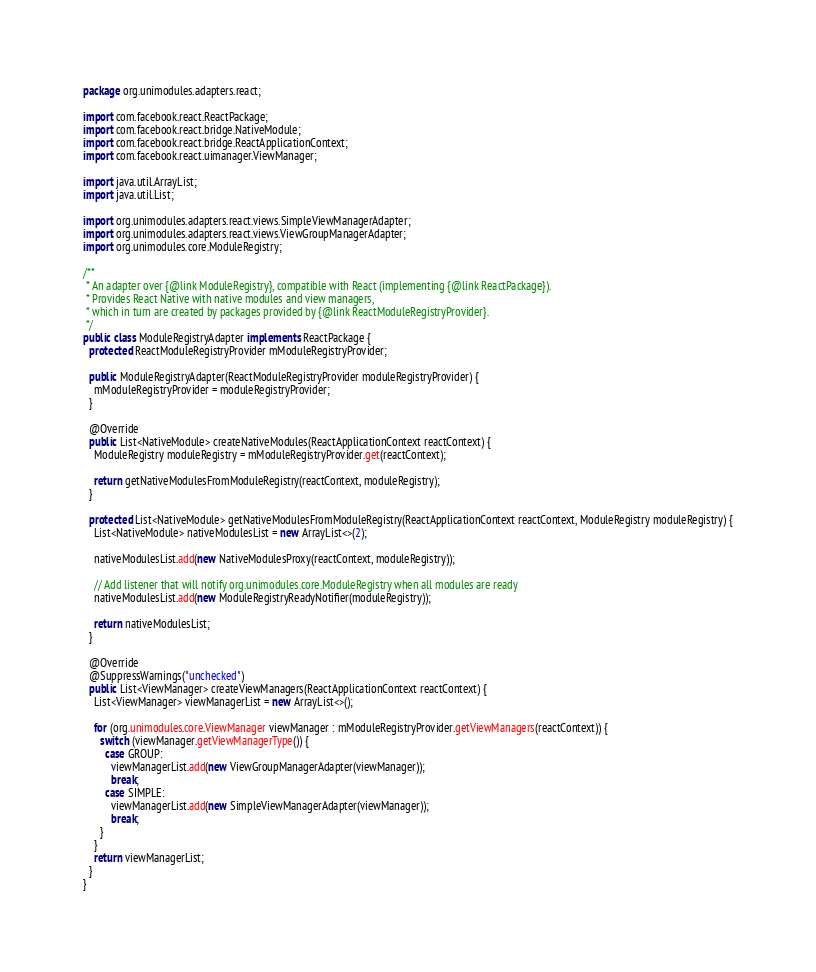Convert code to text. <code><loc_0><loc_0><loc_500><loc_500><_Java_>package org.unimodules.adapters.react;

import com.facebook.react.ReactPackage;
import com.facebook.react.bridge.NativeModule;
import com.facebook.react.bridge.ReactApplicationContext;
import com.facebook.react.uimanager.ViewManager;

import java.util.ArrayList;
import java.util.List;

import org.unimodules.adapters.react.views.SimpleViewManagerAdapter;
import org.unimodules.adapters.react.views.ViewGroupManagerAdapter;
import org.unimodules.core.ModuleRegistry;

/**
 * An adapter over {@link ModuleRegistry}, compatible with React (implementing {@link ReactPackage}).
 * Provides React Native with native modules and view managers,
 * which in turn are created by packages provided by {@link ReactModuleRegistryProvider}.
 */
public class ModuleRegistryAdapter implements ReactPackage {
  protected ReactModuleRegistryProvider mModuleRegistryProvider;

  public ModuleRegistryAdapter(ReactModuleRegistryProvider moduleRegistryProvider) {
    mModuleRegistryProvider = moduleRegistryProvider;
  }

  @Override
  public List<NativeModule> createNativeModules(ReactApplicationContext reactContext) {
    ModuleRegistry moduleRegistry = mModuleRegistryProvider.get(reactContext);

    return getNativeModulesFromModuleRegistry(reactContext, moduleRegistry);
  }

  protected List<NativeModule> getNativeModulesFromModuleRegistry(ReactApplicationContext reactContext, ModuleRegistry moduleRegistry) {
    List<NativeModule> nativeModulesList = new ArrayList<>(2);

    nativeModulesList.add(new NativeModulesProxy(reactContext, moduleRegistry));

    // Add listener that will notify org.unimodules.core.ModuleRegistry when all modules are ready
    nativeModulesList.add(new ModuleRegistryReadyNotifier(moduleRegistry));

    return nativeModulesList;
  }

  @Override
  @SuppressWarnings("unchecked")
  public List<ViewManager> createViewManagers(ReactApplicationContext reactContext) {
    List<ViewManager> viewManagerList = new ArrayList<>();

    for (org.unimodules.core.ViewManager viewManager : mModuleRegistryProvider.getViewManagers(reactContext)) {
      switch (viewManager.getViewManagerType()) {
        case GROUP:
          viewManagerList.add(new ViewGroupManagerAdapter(viewManager));
          break;
        case SIMPLE:
          viewManagerList.add(new SimpleViewManagerAdapter(viewManager));
          break;
      }
    }
    return viewManagerList;
  }
}
</code> 